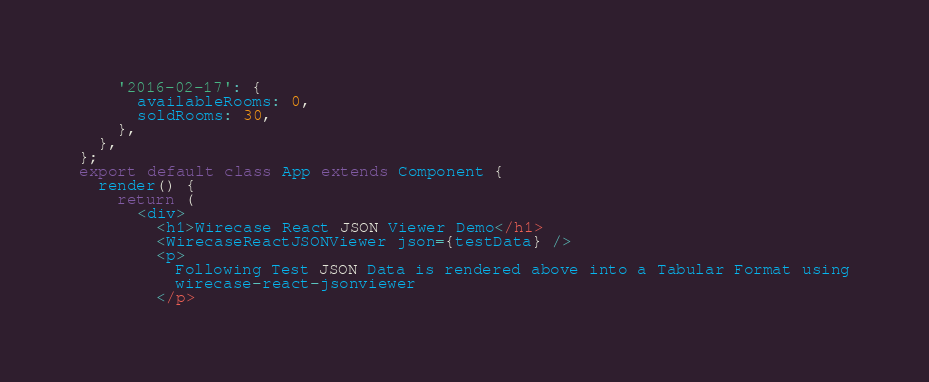<code> <loc_0><loc_0><loc_500><loc_500><_JavaScript_>    '2016-02-17': {
      availableRooms: 0,
      soldRooms: 30,
    },
  },
};
export default class App extends Component {
  render() {
    return (
      <div>
        <h1>Wirecase React JSON Viewer Demo</h1>
        <WirecaseReactJSONViewer json={testData} />
        <p>
          Following Test JSON Data is rendered above into a Tabular Format using
          wirecase-react-jsonviewer
        </p></code> 